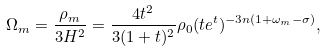<formula> <loc_0><loc_0><loc_500><loc_500>\Omega _ { m } = \frac { \rho _ { m } } { 3 H ^ { 2 } } = \frac { 4 t ^ { 2 } } { 3 ( 1 + t ) ^ { 2 } } \rho _ { 0 } ( t e ^ { t } ) ^ { - 3 n ( 1 + \omega _ { m } - \sigma ) } ,</formula> 